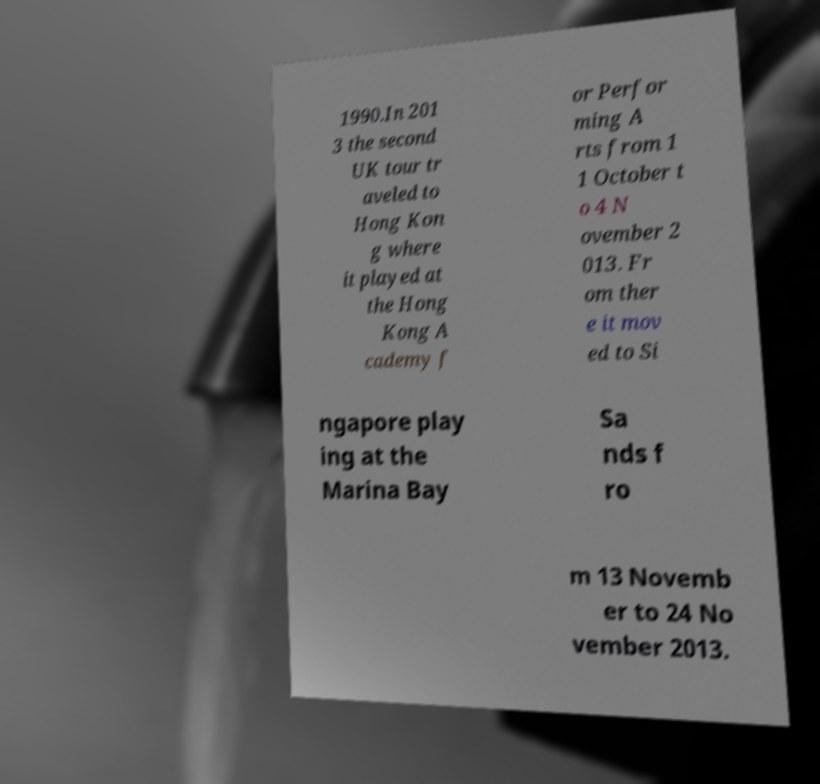Could you extract and type out the text from this image? 1990.In 201 3 the second UK tour tr aveled to Hong Kon g where it played at the Hong Kong A cademy f or Perfor ming A rts from 1 1 October t o 4 N ovember 2 013. Fr om ther e it mov ed to Si ngapore play ing at the Marina Bay Sa nds f ro m 13 Novemb er to 24 No vember 2013. 